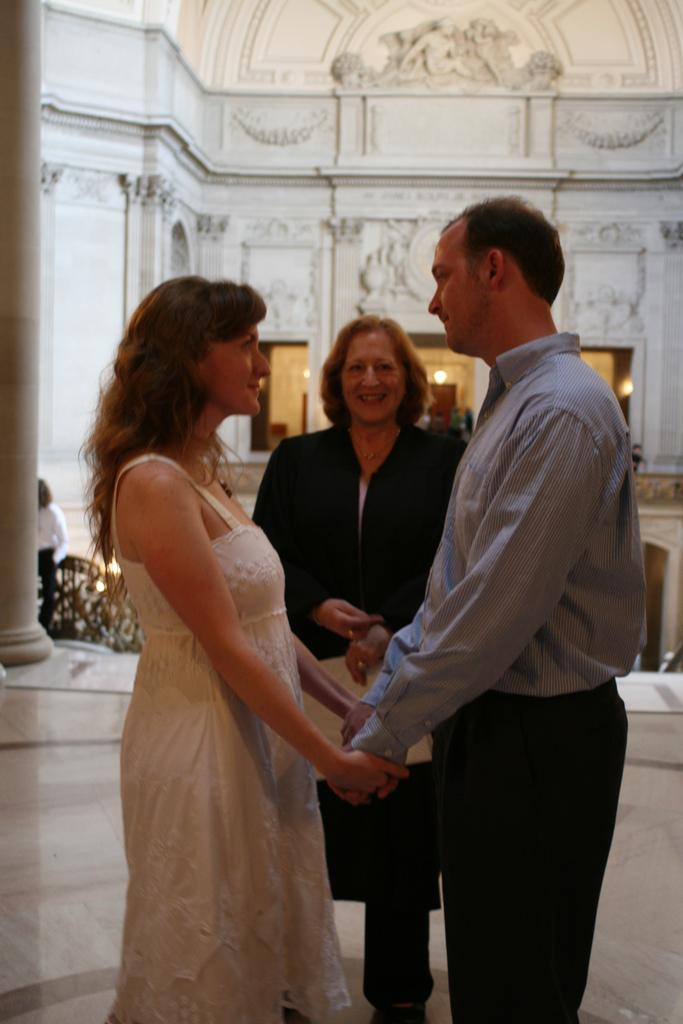How many people are present in the image? There are three people in the image: one man and two women. What are the people in the image doing? The man and women are standing. What can be seen in the background of the image? There is a building in the image. What type of work is being done on the sidewalk in the image? There is no sidewalk or work being done in the image; it only features a man, two women, and a building. 